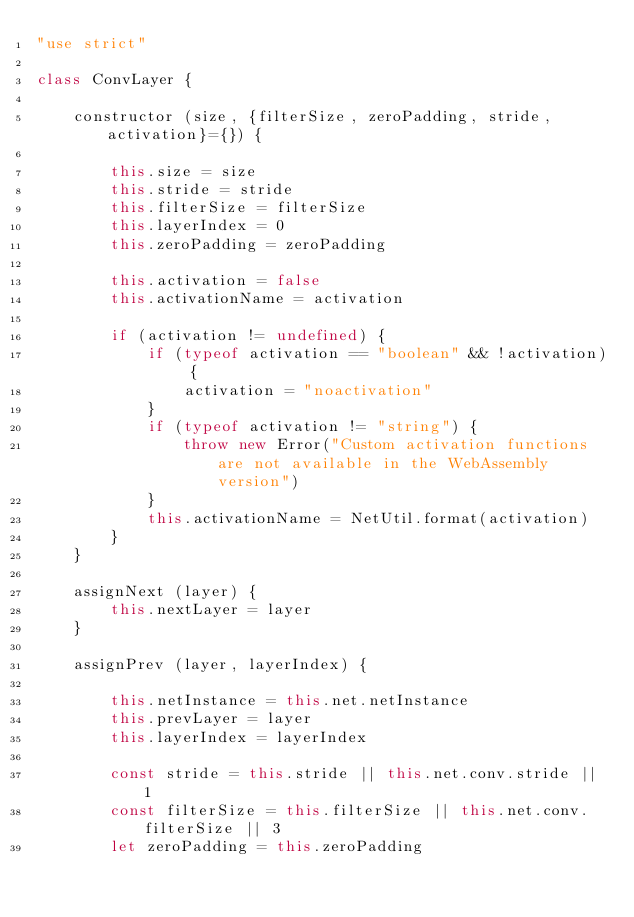<code> <loc_0><loc_0><loc_500><loc_500><_JavaScript_>"use strict"

class ConvLayer {

    constructor (size, {filterSize, zeroPadding, stride, activation}={}) {

        this.size = size
        this.stride = stride
        this.filterSize = filterSize
        this.layerIndex = 0
        this.zeroPadding = zeroPadding

        this.activation = false
        this.activationName = activation

        if (activation != undefined) {
            if (typeof activation == "boolean" && !activation) {
                activation = "noactivation"
            }
            if (typeof activation != "string") {
                throw new Error("Custom activation functions are not available in the WebAssembly version")
            }
            this.activationName = NetUtil.format(activation)
        }
    }

    assignNext (layer) {
        this.nextLayer = layer
    }

    assignPrev (layer, layerIndex) {

        this.netInstance = this.net.netInstance
        this.prevLayer = layer
        this.layerIndex = layerIndex

        const stride = this.stride || this.net.conv.stride || 1
        const filterSize = this.filterSize || this.net.conv.filterSize || 3
        let zeroPadding = this.zeroPadding
</code> 